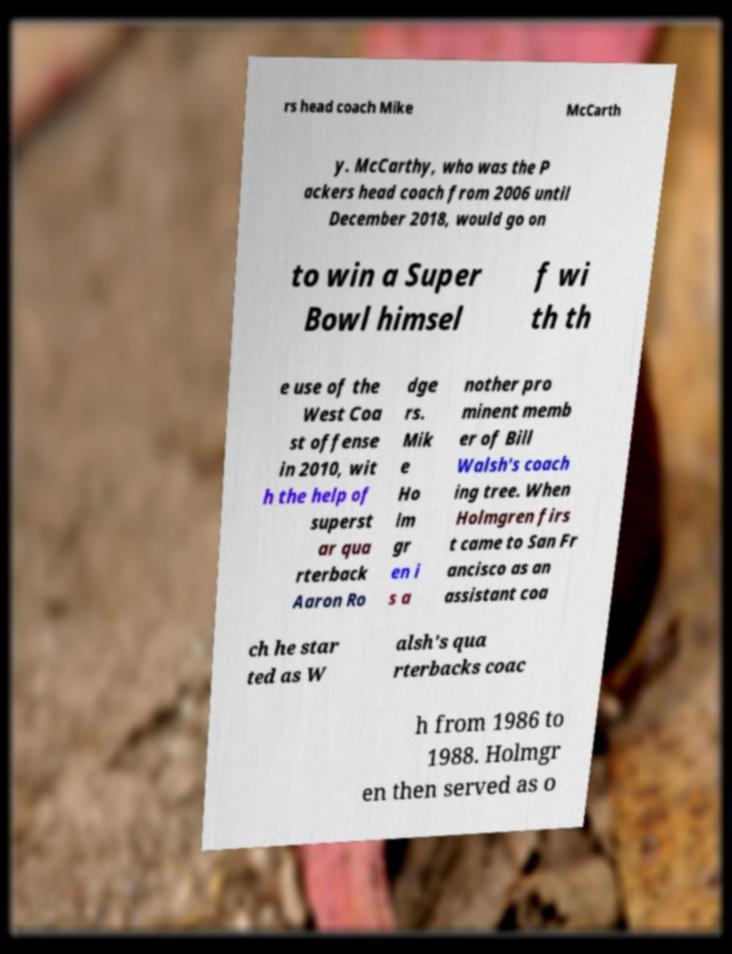Please identify and transcribe the text found in this image. rs head coach Mike McCarth y. McCarthy, who was the P ackers head coach from 2006 until December 2018, would go on to win a Super Bowl himsel f wi th th e use of the West Coa st offense in 2010, wit h the help of superst ar qua rterback Aaron Ro dge rs. Mik e Ho lm gr en i s a nother pro minent memb er of Bill Walsh's coach ing tree. When Holmgren firs t came to San Fr ancisco as an assistant coa ch he star ted as W alsh's qua rterbacks coac h from 1986 to 1988. Holmgr en then served as o 